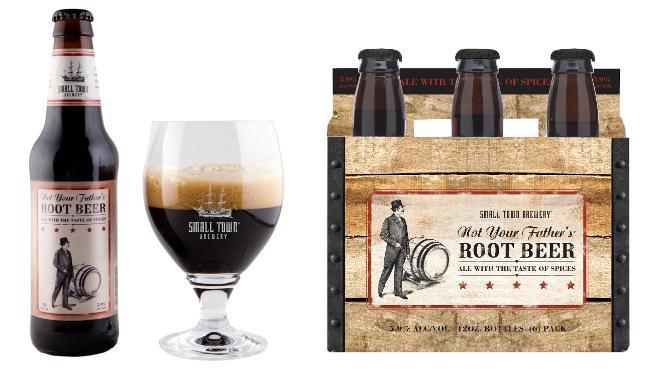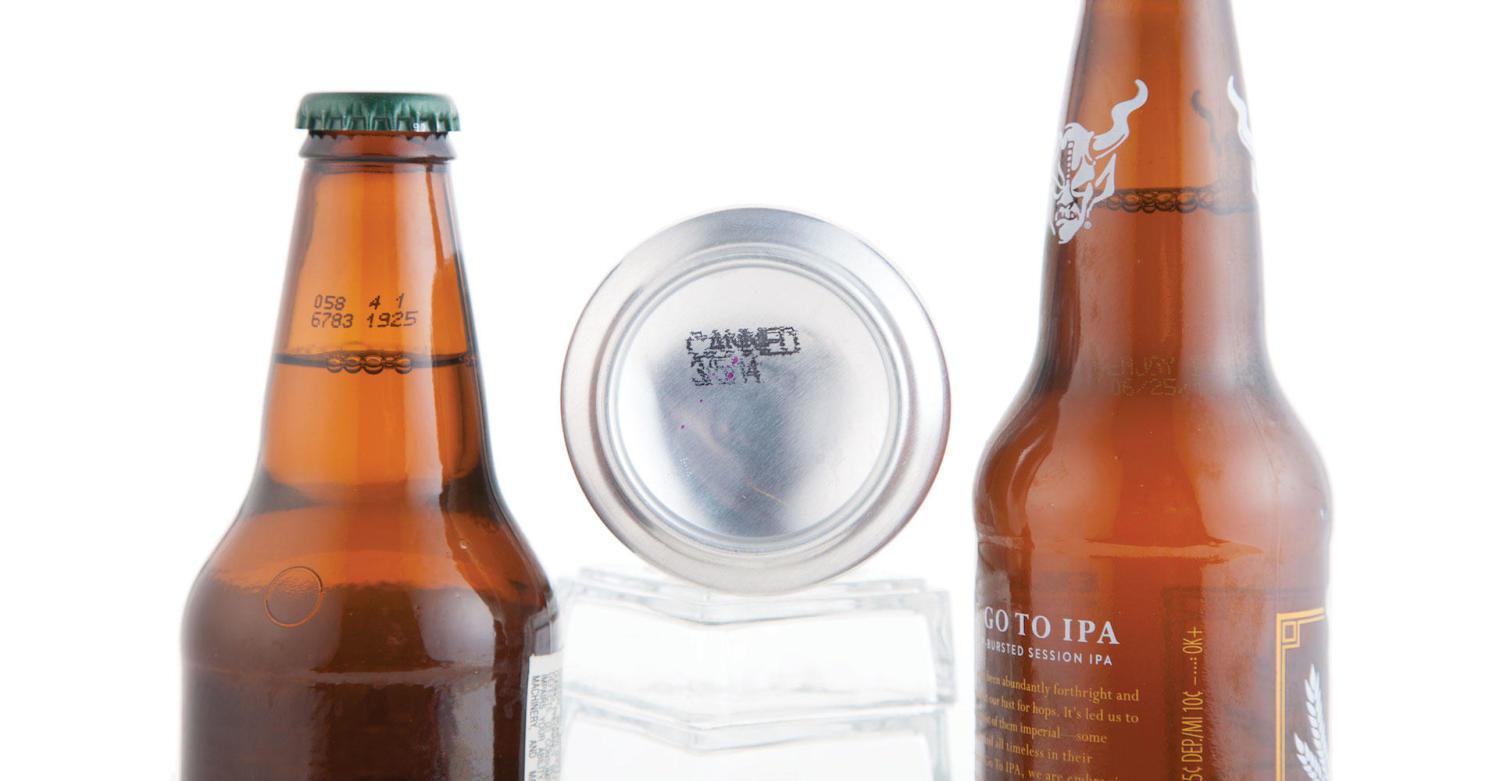The first image is the image on the left, the second image is the image on the right. Given the left and right images, does the statement "In at least one image there are three bottles in a cardboard six pack holder." hold true? Answer yes or no. Yes. The first image is the image on the left, the second image is the image on the right. Evaluate the accuracy of this statement regarding the images: "There are only two bottle visible in the right image.". Is it true? Answer yes or no. Yes. 